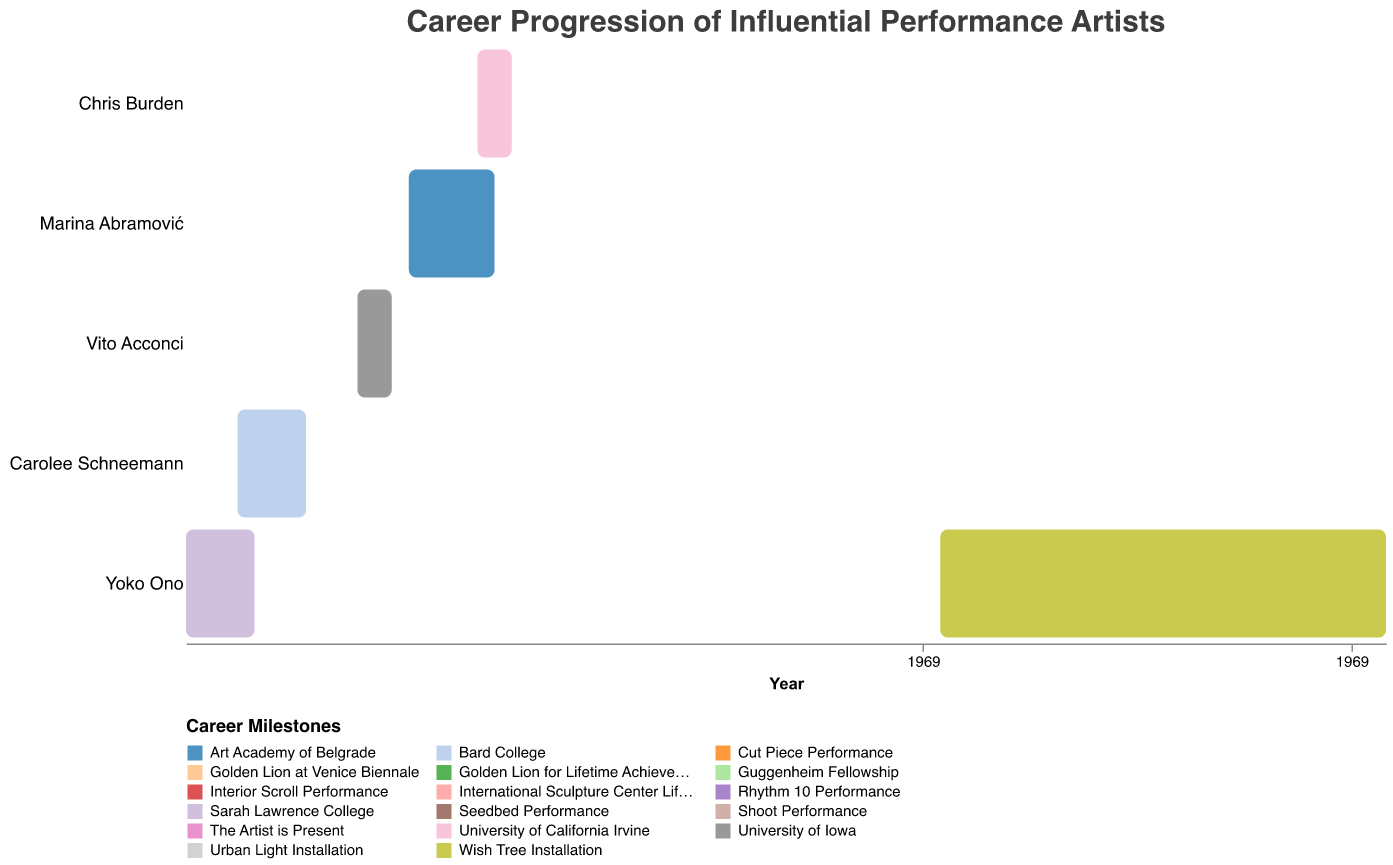Which artist spent the longest time on a single task? Yoko Ono spent the longest time on a single task, as she worked on the "Wish Tree Installation" from 1996 to 2022. This can be determined by observing the duration bars in the Gantt chart and noting the span of years.
Answer: Yoko Ono During which period did Marina Abramović win the Golden Lion at the Venice Biennale? Marina Abramović won the Golden Lion at the Venice Biennale in 1997, which is marked by a single bar for that year on the Gantt chart.
Answer: 1997 How many major performance tasks are listed for Chris Burden? Chris Burden has three major performance tasks listed: "Shoot Performance" in 1971, "Urban Light Installation" in 2008, and "Guggenheim Fellowship" in 1996. This can be confirmed by identifying the bars associated with Chris Burden on the Gantt chart.
Answer: 3 Which artist had their first notable performance work completed the earliest? Yoko Ono completed her first notable performance work, "Cut Piece Performance," in 1964. This is determined by identifying and comparing the earliest start dates for the performance tasks of each artist on the Gantt chart.
Answer: Yoko Ono Compare the academic periods of Carolee Schneemann and Vito Acconci. Which artist finished their academic training earlier? Carolee Schneemann finished her academic training at Bard College in 1959, while Vito Acconci finished at the University of Iowa in 1964. By comparing the end years of their study periods, it's clear that Schneemann completed her training earlier.
Answer: Carolee Schneemann What is the overlap in time between Marina Abramović's "Art Academy of Belgrade" and Yoko Ono's "Sarah Lawrence College"? Marina Abramović was at the Art Academy of Belgrade from 1965 to 1970, and Yoko Ono was at Sarah Lawrence College from 1952 to 1956. There is no overlap between these two periods as the timeframes do not intersect.
Answer: None Which artists received a Lifetime Achievement Award, and when? Yoko Ono received the Golden Lion for Lifetime Achievement in 2009, Carolee Schneemann received it in 2017, and Vito Acconci received the International Sculpture Center Lifetime Achievement Award in 1997. This information is gathered by looking at the bars labeled with those awards.
Answer: Yoko Ono (2009), Carolee Schneemann (2017), Vito Acconci (1997) What is the time span between Vito Acconci's "Seedbed Performance" and his Lifetime Achievement Award? Vito Acconci's "Seedbed Performance" was in 1972, and he received the International Sculpture Center Lifetime Achievement Award in 1997. The time span between these two events is 1997 - 1972 = 25 years.
Answer: 25 years 